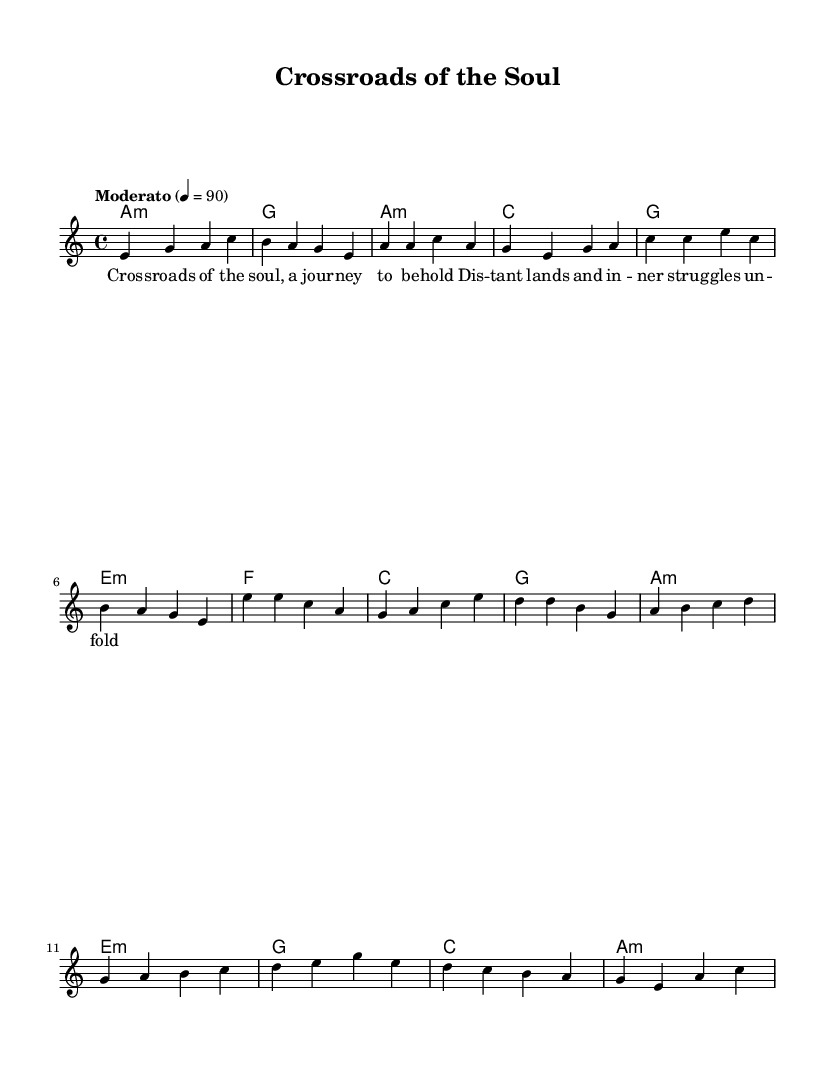What is the key signature of this music? The key signature indicated in the sheet music is A minor, which has no sharps or flats.
Answer: A minor What is the time signature of this music? The time signature shown in the score is 4/4, which means there are four beats in a measure and a quarter note receives one beat.
Answer: 4/4 What is the tempo marking for this piece? The tempo marking is "Moderato," which typically suggests a moderate pace, and the tempo specific marking is 4=90, indicating the metronome beat.
Answer: Moderato How many measures are in the chorus section? By analyzing the sheet music, there are four measures present in the chorus section, where the melodic and harmonic patterns change.
Answer: 4 What type of chord is used in the introduction? The introduction utilizes an A minor chord, as indicated by the notation "a1:m" in the harmonies section.
Answer: A minor What storytelling element is reflected in the lyrics? The lyrics depict a journey through distant lands and inner struggles, characteristic of storytelling elements common in blues and world music.
Answer: Journey What traditional music styles influence this fusion piece? This piece is influenced by blues and world music styles, which intertwine storytelling and reflective themes within their structures.
Answer: Blues and world music 